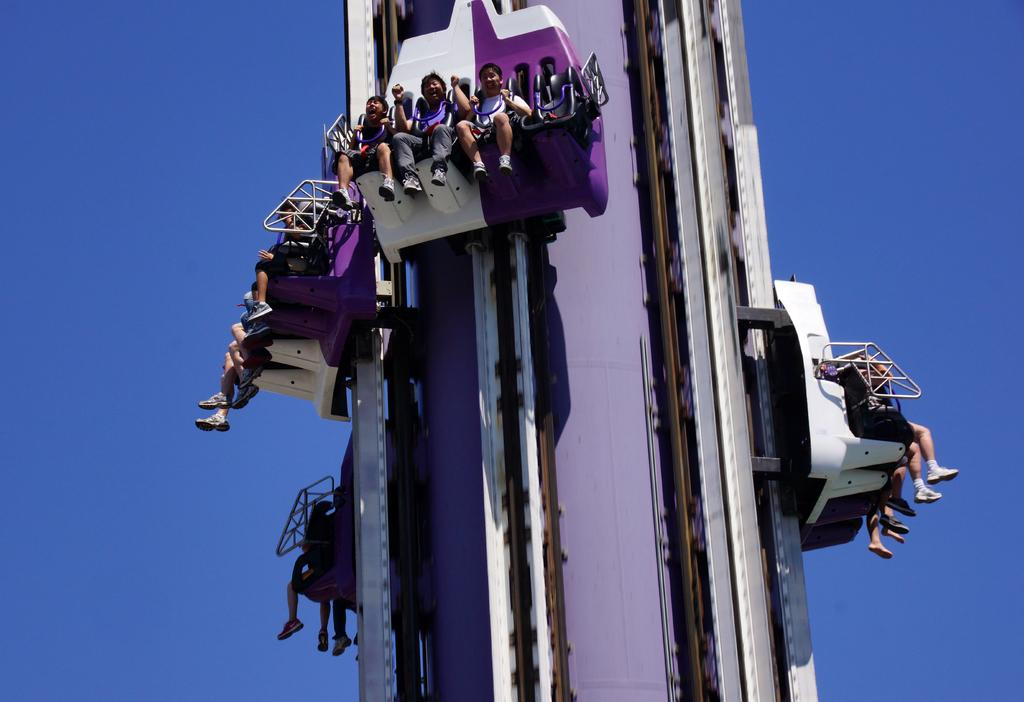How many people are in the image? There is a group of people in the image. What are the people doing in the image? The people are sitting on a ride. What can be seen in the background of the image? The sky is visible in the background of the image. What is the color of the sky in the image? The color of the sky is blue. What type of oil is being used to lubricate the ride in the image? There is no mention of oil or any mechanical components in the image; it simply shows a group of people sitting on a ride. 